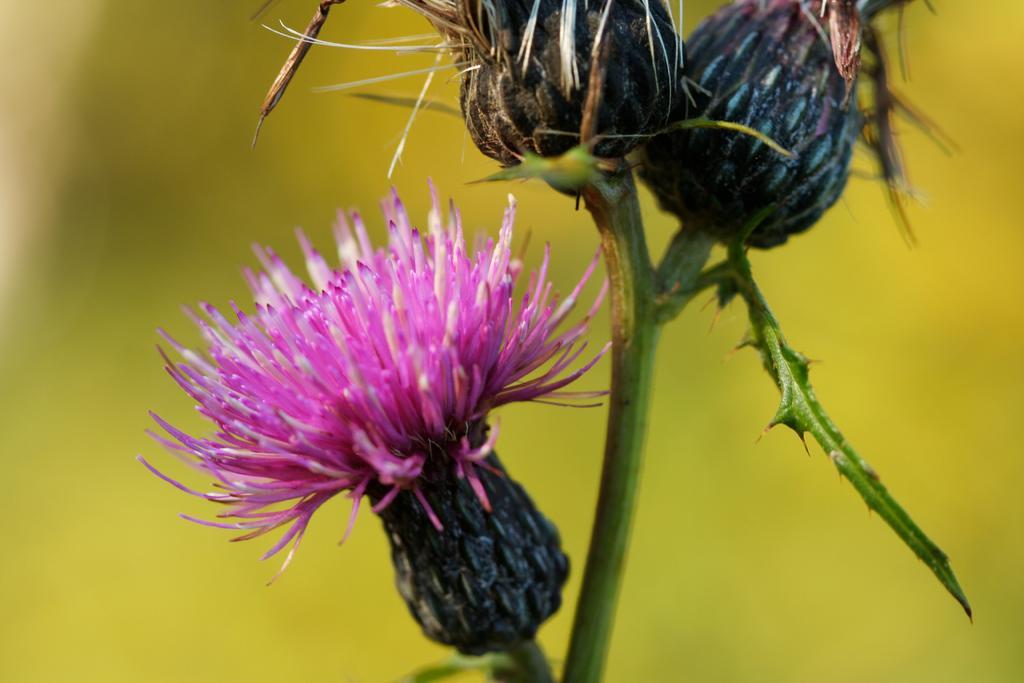In one or two sentences, can you explain what this image depicts? There is a pink color flower on a stem. On the storm there is a leaf with thorns. In the background it is blurred. 